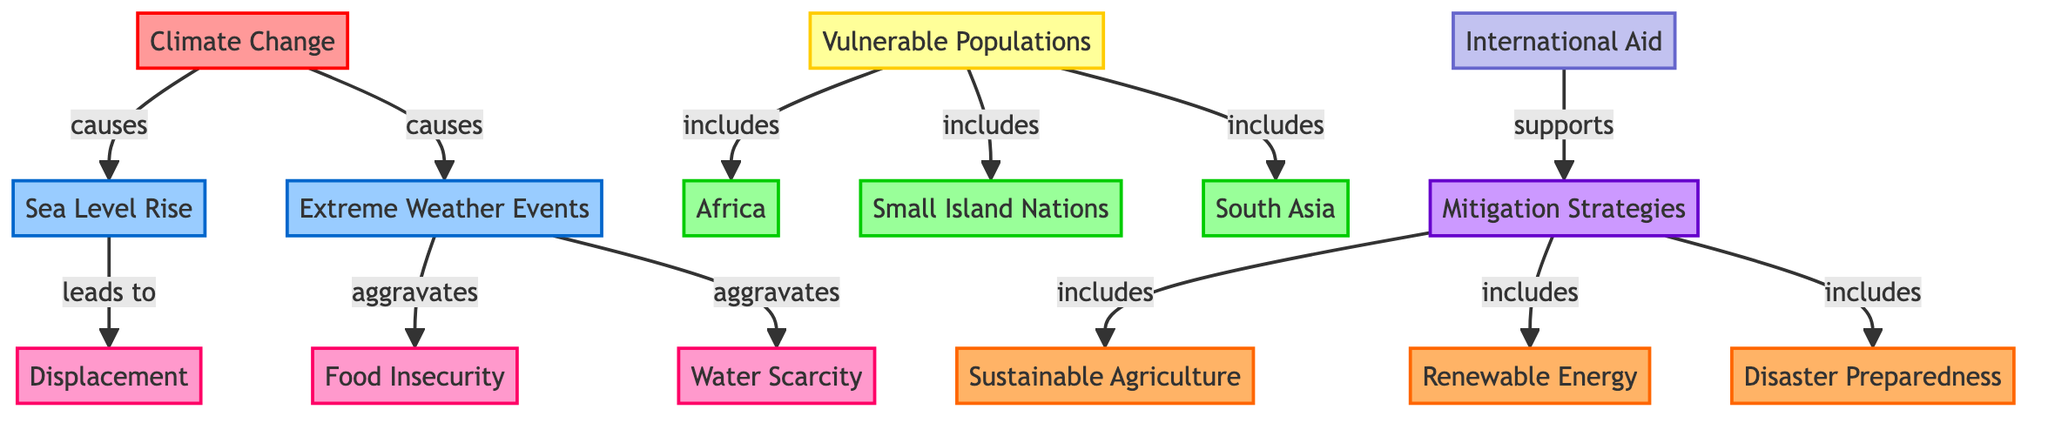What are the main factors caused by climate change? The diagram directly links "Climate Change" to two factors: "Sea Level Rise" and "Extreme Weather Events," indicating these are the primary effects associated with climate change.
Answer: Sea Level Rise, Extreme Weather Events How many regions are identified as vulnerable populations? The diagram shows three specific regions categorized as vulnerable populations: "Africa," "Small Island Nations," and "South Asia."
Answer: Three Which mitigation strategy is directly tied to international aid? The diagram illustrates that "International Aid" supports "Mitigation Strategies," meaning any efforts to mitigate can be backed by international assistance.
Answer: Mitigation Strategies What issues are aggravated by extreme weather events? According to the diagram, "Extreme Weather Events" aggravate two specific issues: "Food Insecurity" and "Water Scarcity."
Answer: Food Insecurity, Water Scarcity What is the relationship between sea level rise and displacement? The diagram illustrates that "Sea Level Rise" leads to "Displacement," indicating a direct consequence of rising sea levels on populations.
Answer: Leads to Explain how extreme weather events relate to vulnerable populations. "Extreme Weather Events" aggravate issues like "Food Insecurity" and "Water Scarcity," which are critical for the well-being of vulnerable populations identified in the diagram, linking these phenomena together. The vulnerable populations are impacted through these aggravated issues.
Answer: They aggravate issues affecting them What are the actions included in mitigation strategies? The diagram specifies three actions under "Mitigation Strategies": "Sustainable Agriculture," "Renewable Energy," and "Disaster Preparedness." Each of these actions is listed as a strategy to combat impacts caused by climate change.
Answer: Sustainable Agriculture, Renewable Energy, Disaster Preparedness Which regions include vulnerable populations? The diagram categorizes "Vulnerable Populations" into three distinct regions namely "Africa," "Small Island Nations," and "South Asia." Each of these regions falls under the group of vulnerable communities affected by climate change.
Answer: Africa, Small Island Nations, South Asia How does climate change affect food security? The relationship depicted in the diagram shows that "Climate Change" causes "Extreme Weather Events," which subsequently aggravate "Food Insecurity," demonstrating a direct pathway from climate change to food security issues.
Answer: Aggravates food insecurity What are the consequences of sea level rise according to the diagram? The diagram clearly states that one consequence of "Sea Level Rise" is "Displacement," indicating that areas affected by rising sea levels will face issues of population displacement.
Answer: Displacement 